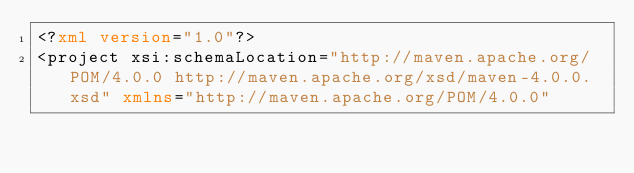Convert code to text. <code><loc_0><loc_0><loc_500><loc_500><_XML_><?xml version="1.0"?>
<project xsi:schemaLocation="http://maven.apache.org/POM/4.0.0 http://maven.apache.org/xsd/maven-4.0.0.xsd" xmlns="http://maven.apache.org/POM/4.0.0"</code> 